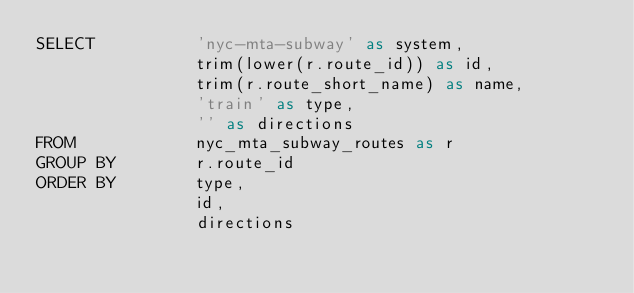Convert code to text. <code><loc_0><loc_0><loc_500><loc_500><_SQL_>SELECT          'nyc-mta-subway' as system,
                trim(lower(r.route_id)) as id,
                trim(r.route_short_name) as name,
                'train' as type,
                '' as directions
FROM            nyc_mta_subway_routes as r
GROUP BY        r.route_id
ORDER BY        type,
                id,
                directions
</code> 